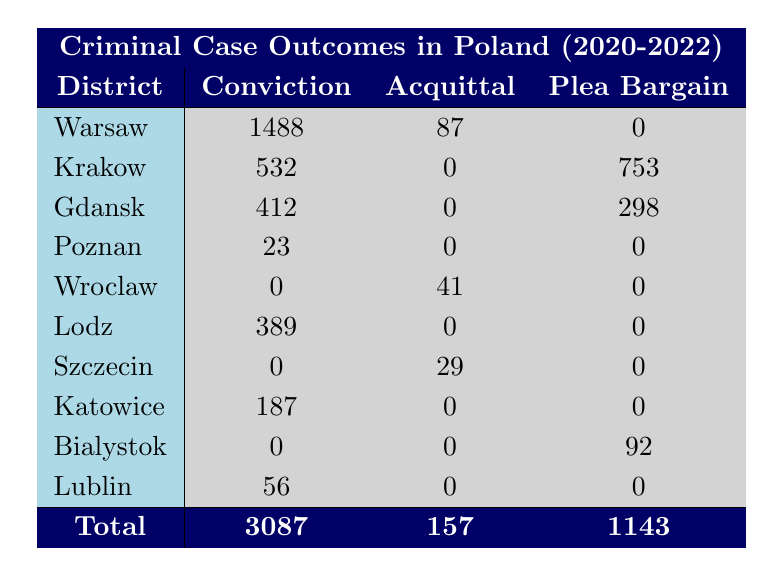What is the total number of convictions recorded in Warsaw from 2020 to 2022? In the table, under the "Warsaw" row, the conviction counts are 1245 for 2020, 176 for 2021, and 67 for 2022. Adding these gives: 1245 + 176 + 67 = 1488.
Answer: 1488 Which district had the highest number of acquittals in total? By examining the acquittal counts in each district, Warsaw has 87 (2020), Wroclaw has 41 (2021), Szczecin has 29 (2022), and others have 0. The highest count is 87 from Warsaw.
Answer: Warsaw What is the combined total of plea bargains across all districts? The plea bargain counts in the table are: Gdansk 298 (2020), Krakow 753 (2022), Bialystok 92 (2021), leading to a total: 298 + 753 + 92 = 1143.
Answer: 1143 Did any cases of theft result in acquittals in Krakow? In the table, under the "Krakow" row, the theft case shows a conviction count of 532 and 0 acquittals, hence no theft resulted in acquittals.
Answer: No What is the difference between the total number of convictions and the total number of acquittals recorded in Poland from 2020 to 2022? Total convictions are 3087 and total acquittals are 157. The difference is 3087 - 157 = 2930.
Answer: 2930 Which case type had the highest count of convictions in the entire dataset? By reviewing the conviction counts for each case type, Theft in Warsaw has the highest count of 1245.
Answer: Theft How many districts recorded both convictions and acquittals? The districts with convictions are Warsaw, Krakow, Gdansk, Poznan, Lodz, Katowice, Bialystok, and Lublin. Acquittals are only present in Wroclaw, Szczecin, and Warsaw. Both convictions and acquittals can be found in Warsaw. Therefore, only one district has both.
Answer: 1 Are there any years when there were no convictions recorded in Wroclaw? According to the table, Wroclaw has a count of 0 convictions in 2020 and 2022 while only having 41 acquittals in 2021, confirming no convictions across the listed years.
Answer: Yes What percentage of total cases were resolved through plea bargains? Total cases are 3087 (convictions) + 157 (acquittals) + 1143 (plea bargains) = 4187. The count of plea bargains is 1143. The percentage is (1143 / 4187) * 100 ≈ 27.3%.
Answer: 27.3% 